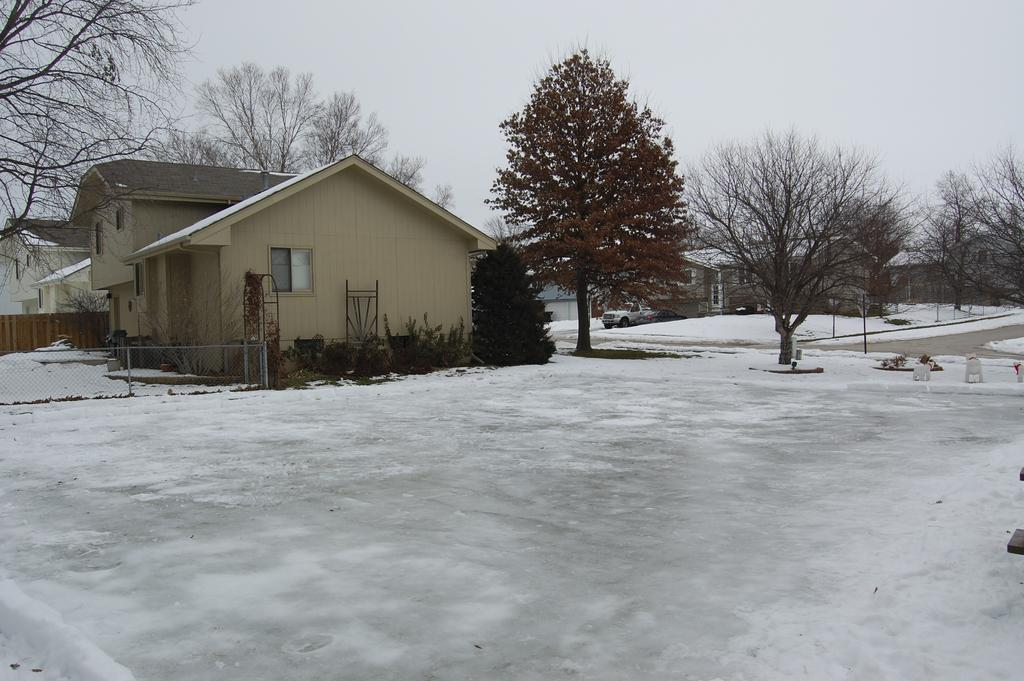What type of natural phenomenon is present at the bottom of the image? There is snow on the surface at the bottom of the image. What can be seen on the left side of the image? There is a metal fence on the left side of the image. What is visible in the background of the image? There are trees, buildings, and the sky visible in the background of the image. What type of music can be heard coming from the snails in the image? There are no snails present in the image, so it is not possible to determine what, if any, music might be heard. What is the snail using to carry the bucket in the image? There are no snails or buckets present in the image. 